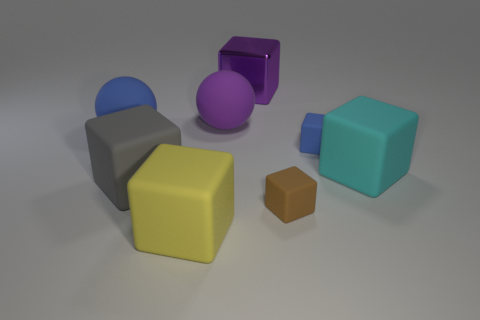There is a large cyan matte thing; are there any small cubes in front of it?
Offer a terse response. Yes. Does the large purple thing in front of the large purple metal block have the same shape as the blue thing on the left side of the small brown cube?
Keep it short and to the point. Yes. What is the material of the purple thing that is the same shape as the large blue thing?
Offer a terse response. Rubber. How many spheres are big purple matte things or big gray objects?
Offer a terse response. 1. What number of other large cyan objects have the same material as the big cyan thing?
Provide a short and direct response. 0. Are the ball to the left of the big purple ball and the big block that is behind the cyan object made of the same material?
Provide a short and direct response. No. What number of tiny cubes are behind the big object right of the large cube that is behind the big cyan object?
Your answer should be very brief. 1. There is a large block behind the big blue thing; does it have the same color as the large rubber sphere that is behind the blue ball?
Your response must be concise. Yes. There is a object in front of the tiny matte block in front of the big gray thing; what is its color?
Your answer should be very brief. Yellow. Are any big red blocks visible?
Offer a very short reply. No. 